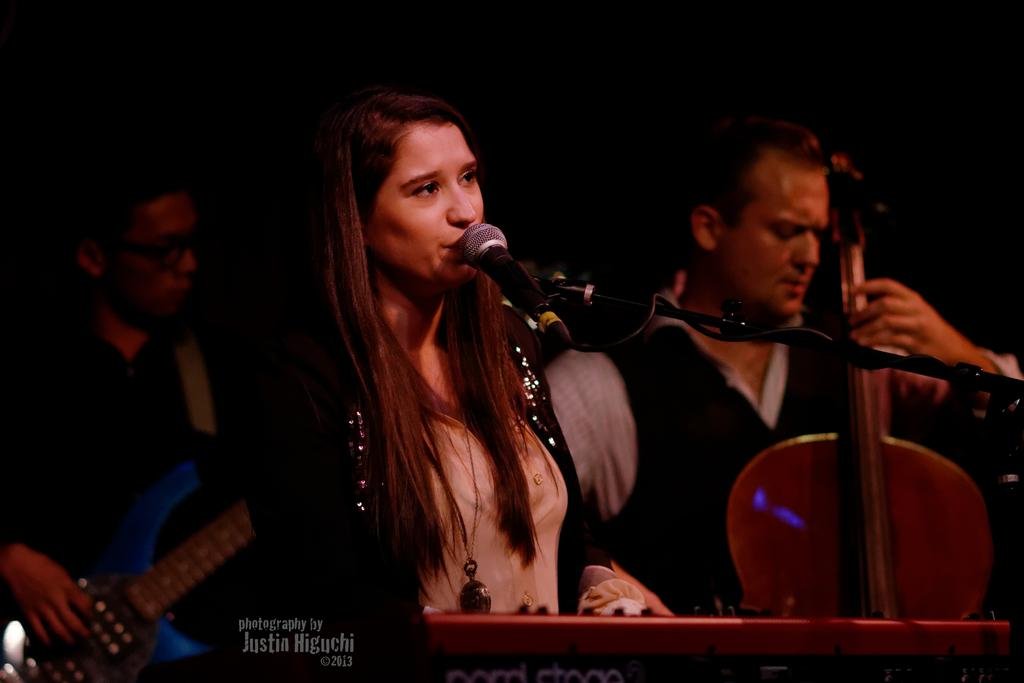Who is the main subject in the image? There is a woman in the image. What is the woman doing in the image? The woman is singing into a microphone. Are there any other people in the image? Yes, there are two men in the image. What are the men doing in the image? The men are playing musical instruments. Can you describe the background of the image? The background of the image is dark. What type of cabbage is being sold in the image? There is no shop or cabbage present in the image. Can you tell me how many family members are visible in the image? The image does not depict a family setting, and there are no family members mentioned in the provided facts. 